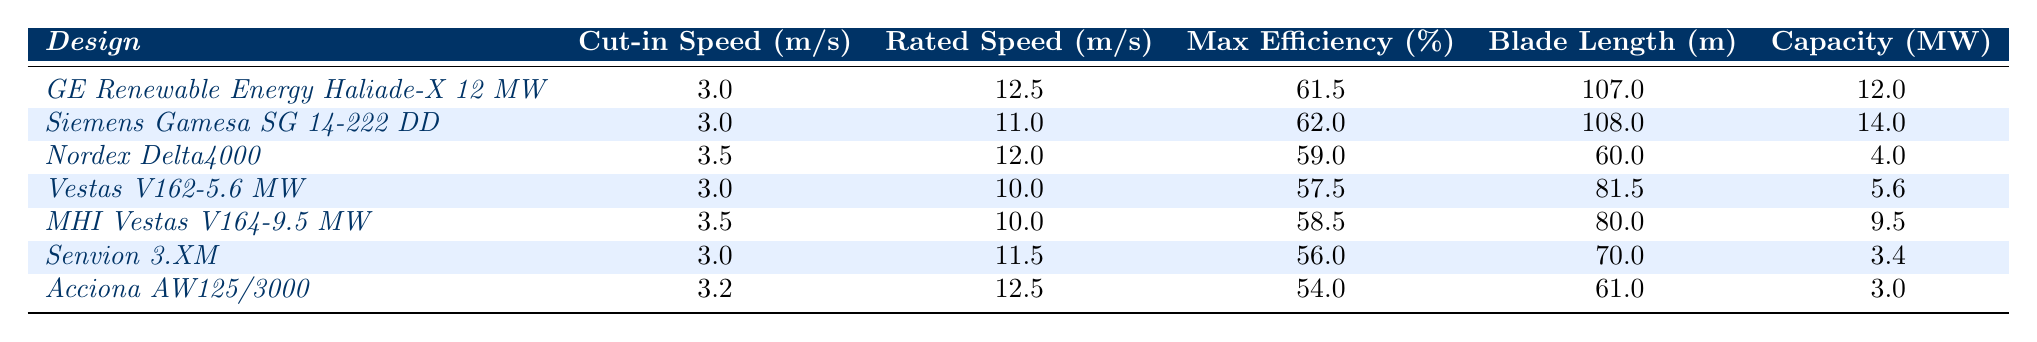What is the maximum efficiency of the Siemens Gamesa SG 14-222 DD? The table lists the maximum efficiency of each design. For Siemens Gamesa SG 14-222 DD, the value is clearly shown as 62.0%.
Answer: 62.0% Which wind turbine has the longest blade length? The blade lengths are provided for each turbine design. Comparing these, the Siemens Gamesa SG 14-222 DD has the longest blade length of 108 meters.
Answer: 108 meters What is the average rated speed of all the wind turbines listed? The rated speeds are: 12.5, 11.0, 12.0, 10.0, 10.0, 11.5, 12.5. Adding these gives 12.5 + 11.0 + 12.0 + 10.0 + 10.0 + 11.5 + 12.5 =  79.5. There are 7 turbines, so the average is 79.5 / 7 = 11.36 m/s.
Answer: 11.36 m/s Which wind turbine has the highest capacity and what is its efficiency? The capacities are: 12, 14, 4, 5.6, 9.5, 3.4, 3.0. The Siemens Gamesa SG 14-222 DD has the highest capacity of 14 MW and its efficiency is 62.0%.
Answer: 14 MW, 62.0% Is the maximum efficiency of Vestas V162-5.6 MW greater than that of Senvion 3.XM? The maximum efficiency for Vestas V162-5.6 MW is 57.5% and for Senvion 3.XM is 56.0%. Since 57.5% is greater than 56.0%, the statement is true.
Answer: Yes What is the difference in max efficiency between the GE Renewable Energy Haliade-X 12 MW and MHI Vestas V164-9.5 MW? The maximum efficiency of GE Renewable Energy Haliade-X 12 MW is 61.5%, while for MHI Vestas V164-9.5 MW it is 58.5%. The difference is 61.5% - 58.5% = 3.0%.
Answer: 3.0% If you consider a turbine with a cut-in speed of 3.0 m/s, which turbines qualify and what are their max efficiencies? The turbines with a cut-in speed of 3.0 m/s are GE Renewable Energy Haliade-X 12 MW, Siemens Gamesa SG 14-222 DD, Vestas V162-5.6 MW, and Senvion 3.XM. Their max efficiencies are 61.5%, 62.0%, 57.5%, and 56.0% respectively.
Answer: 61.5%, 62.0%, 57.5%, 56.0% What is the relationship between blade length and capacity for the Nordex Delta4000? The blade length of Nordex Delta4000 is 60 meters, and its capacity is 4.0 MW. This is a specific relationship and does not indicate an overall correlation in the table for all designs.
Answer: 60 m, 4.0 MW Which two turbines have the same cut-in speed and what are their rated speeds? The turbines with a cut-in speed of 3.0 m/s are GE Renewable Energy Haliade-X 12 MW, Siemens Gamesa SG 14-222 DD, and Vestas V162-5.6 MW. Their rated speeds are 12.5 m/s, 11.0 m/s, and 10.0 m/s respectively.
Answer: 12.5 m/s, 11.0 m/s, 10.0 m/s 